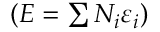Convert formula to latex. <formula><loc_0><loc_0><loc_500><loc_500>\left ( E = \sum N _ { i } \varepsilon _ { i } \right )</formula> 